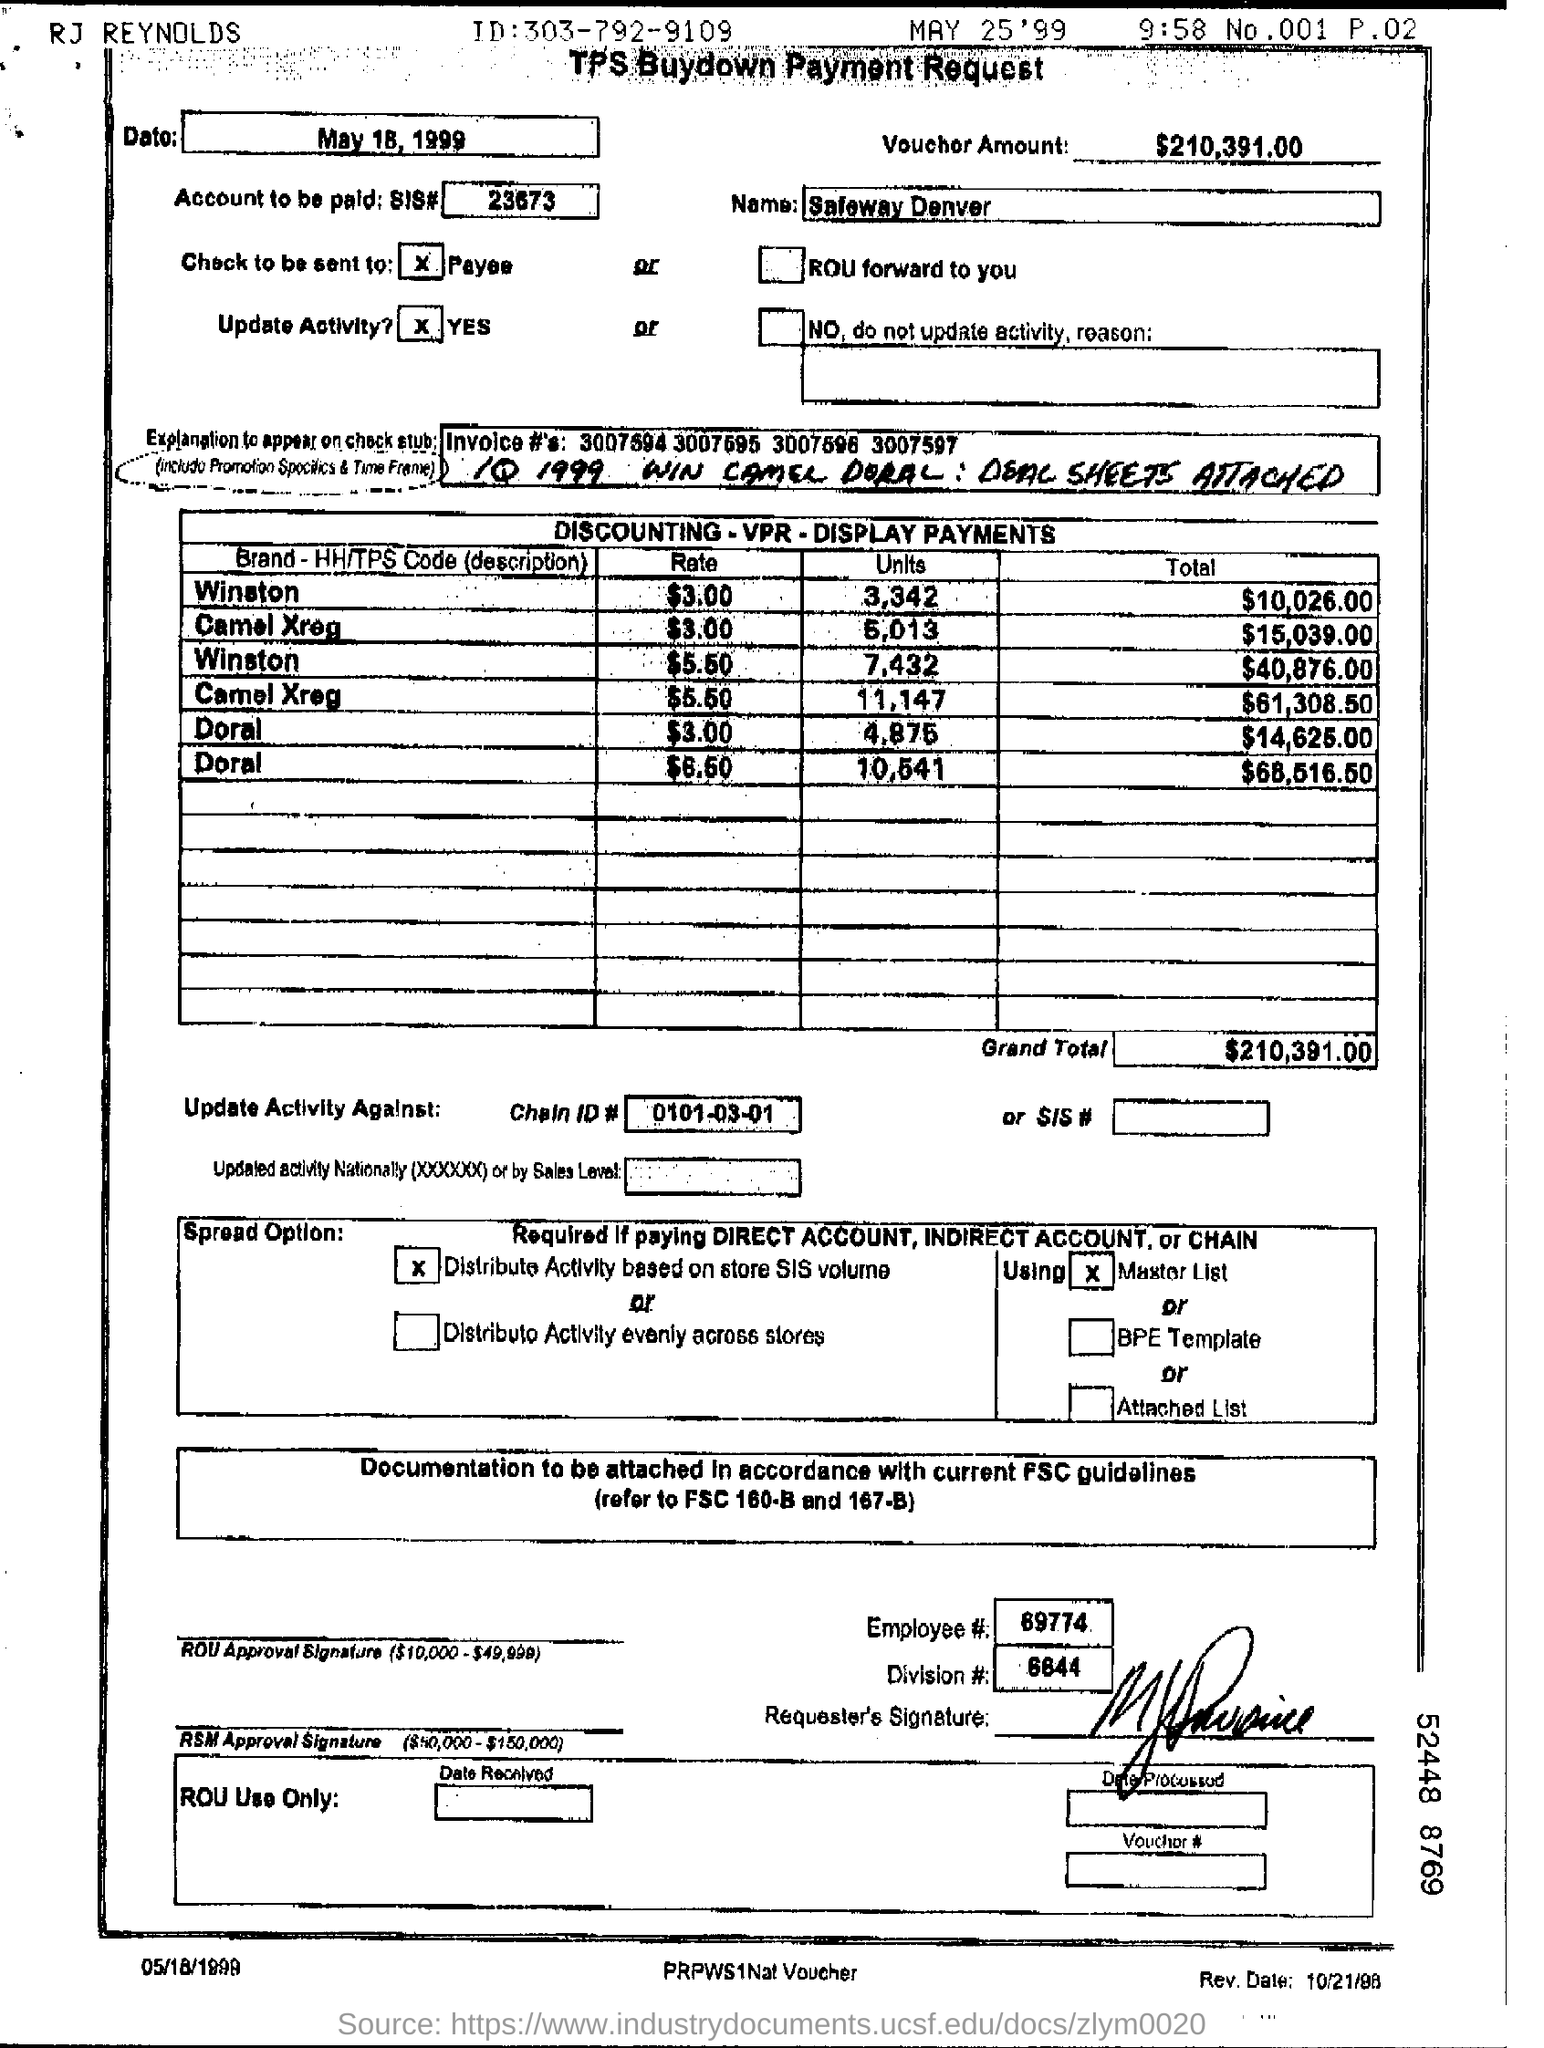Indicate a few pertinent items in this graphic. The voucher amount is $210,391.00. 